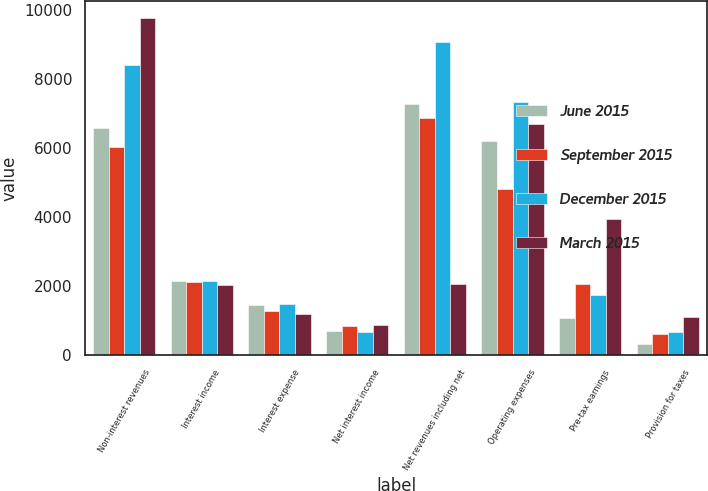<chart> <loc_0><loc_0><loc_500><loc_500><stacked_bar_chart><ecel><fcel>Non-interest revenues<fcel>Interest income<fcel>Interest expense<fcel>Net interest income<fcel>Net revenues including net<fcel>Operating expenses<fcel>Pre-tax earnings<fcel>Provision for taxes<nl><fcel>June 2015<fcel>6573<fcel>2148<fcel>1448<fcel>700<fcel>7273<fcel>6201<fcel>1072<fcel>307<nl><fcel>September 2015<fcel>6019<fcel>2119<fcel>1277<fcel>842<fcel>6861<fcel>4815<fcel>2046<fcel>620<nl><fcel>December 2015<fcel>8406<fcel>2150<fcel>1487<fcel>663<fcel>9069<fcel>7343<fcel>1726<fcel>678<nl><fcel>March 2015<fcel>9758<fcel>2035<fcel>1176<fcel>859<fcel>2046<fcel>6683<fcel>3934<fcel>1090<nl></chart> 